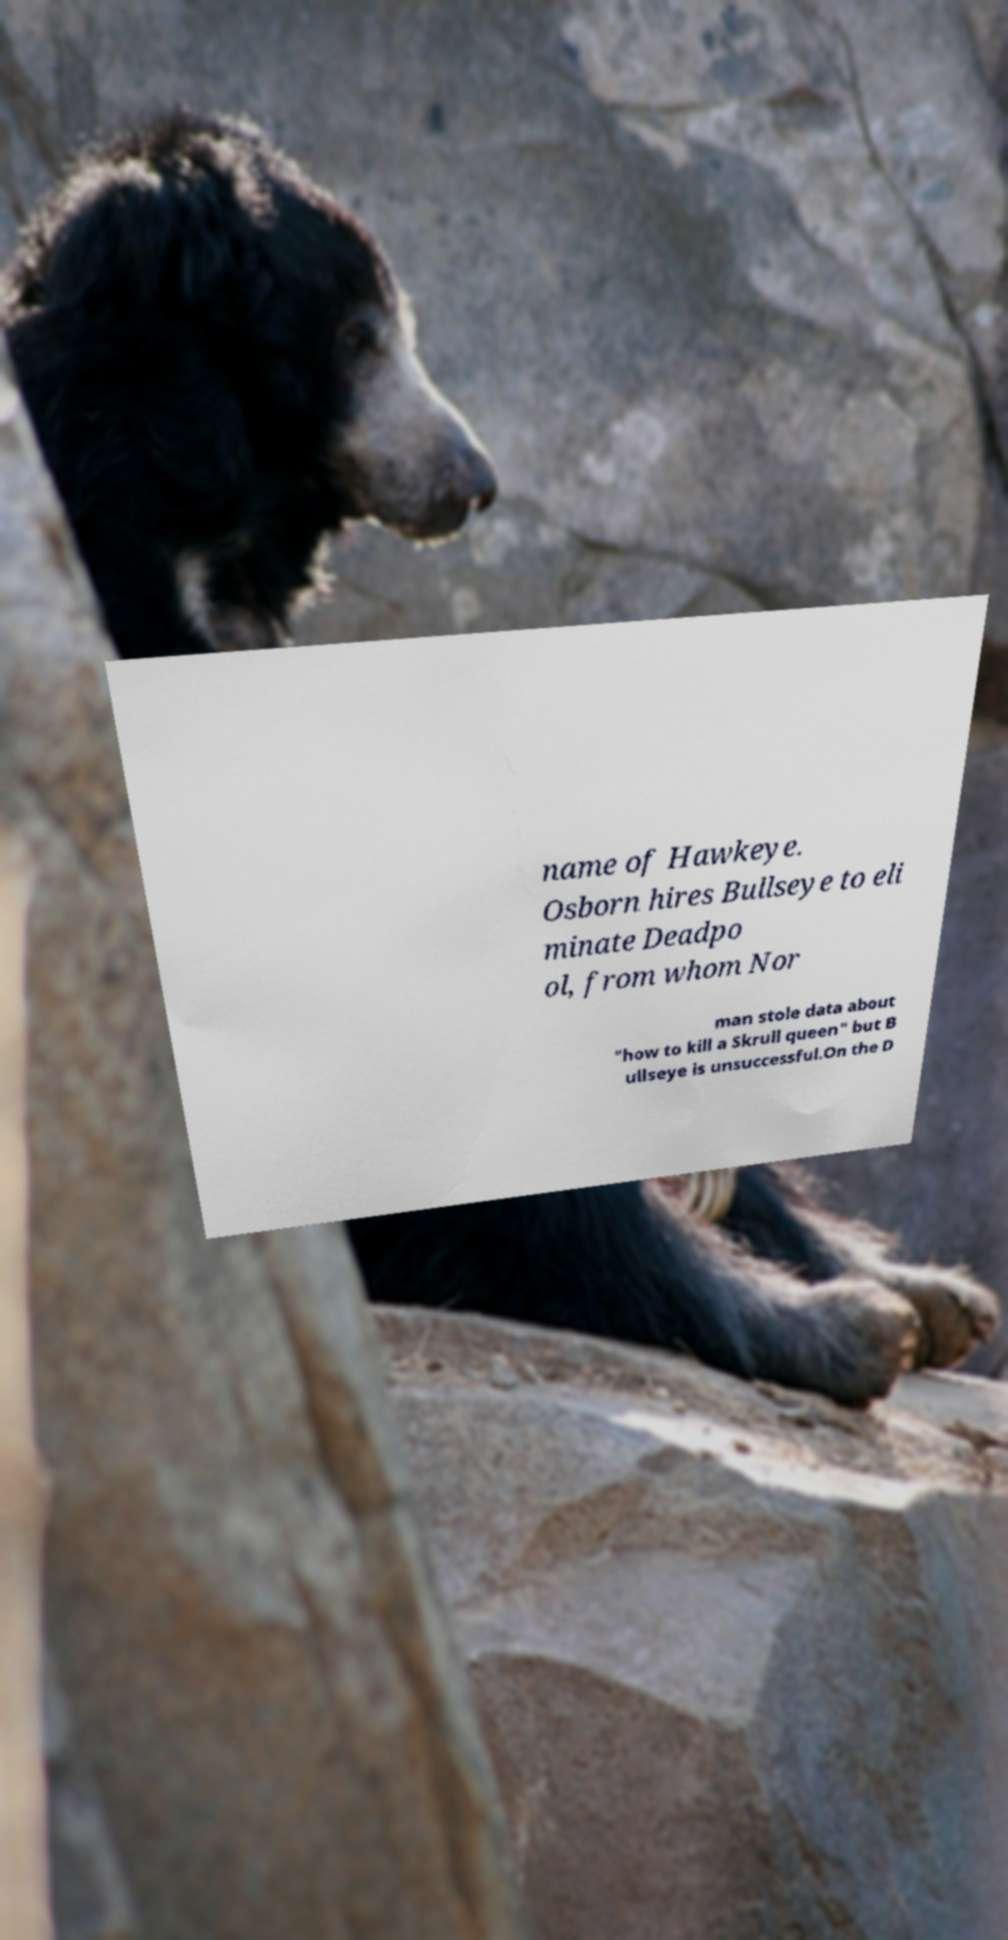What messages or text are displayed in this image? I need them in a readable, typed format. name of Hawkeye. Osborn hires Bullseye to eli minate Deadpo ol, from whom Nor man stole data about "how to kill a Skrull queen" but B ullseye is unsuccessful.On the D 